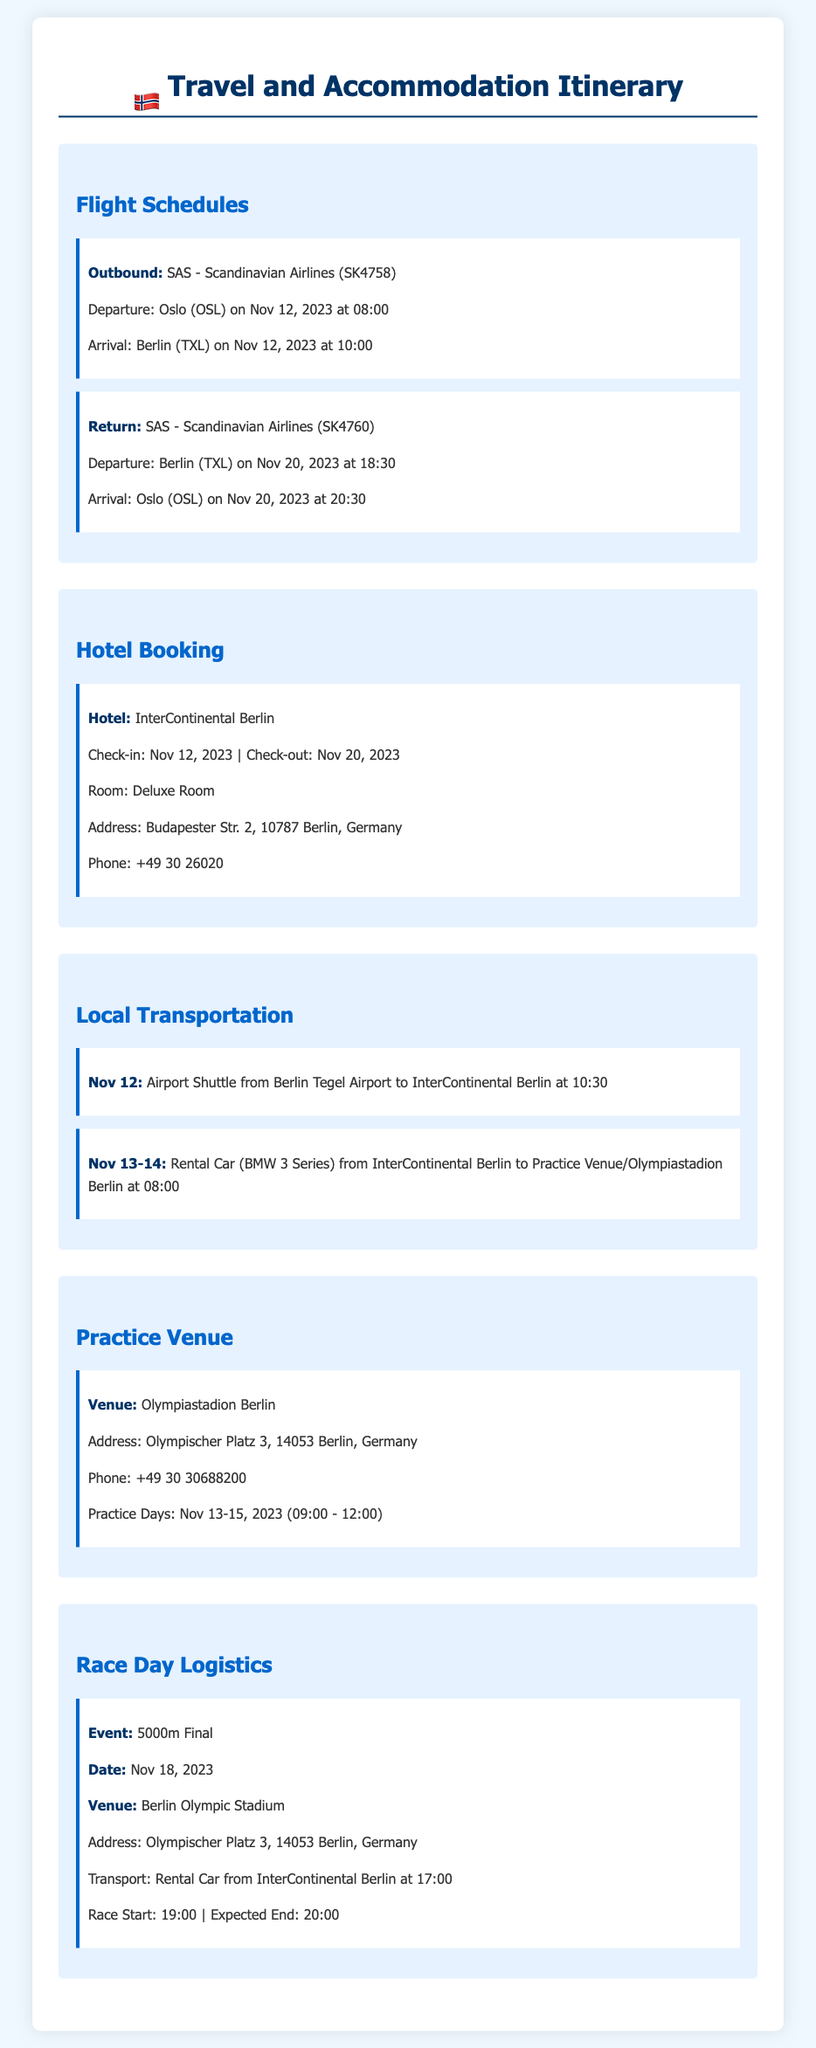what is the flight number for the outbound flight? The flight number for the outbound flight listed in the itinerary is SK4758.
Answer: SK4758 what is the check-in date for the hotel? The check-in date for the hotel is specified as November 12, 2023.
Answer: November 12, 2023 which hotel is booked for the stay? The hotel booked for the stay is the InterContinental Berlin.
Answer: InterContinental Berlin what time does the race start? The race start time provided in the document is 19:00.
Answer: 19:00 how many days of practice are scheduled? The document states that practice days are scheduled from November 13 to November 15, which is a total of 3 days.
Answer: 3 days what mode of transportation is arranged on Nov 12? The mode of transportation arranged on November 12 is an airport shuttle.
Answer: airport shuttle what is the address of the practice venue? The address of the practice venue is mentioned as Olympischer Platz 3, 14053 Berlin, Germany.
Answer: Olympischer Platz 3, 14053 Berlin, Germany what is the expected end time for the race? The expected end time for the race is stated as 20:00.
Answer: 20:00 where will the 5000m final take place? The venue for the 5000m final is the Berlin Olympic Stadium.
Answer: Berlin Olympic Stadium 